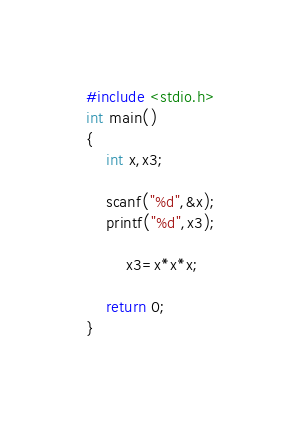<code> <loc_0><loc_0><loc_500><loc_500><_C_>#include <stdio.h>
int main()
{
	int x,x3;

	scanf("%d",&x);
	printf("%d",x3);

        x3=x*x*x;

	return 0;
}</code> 